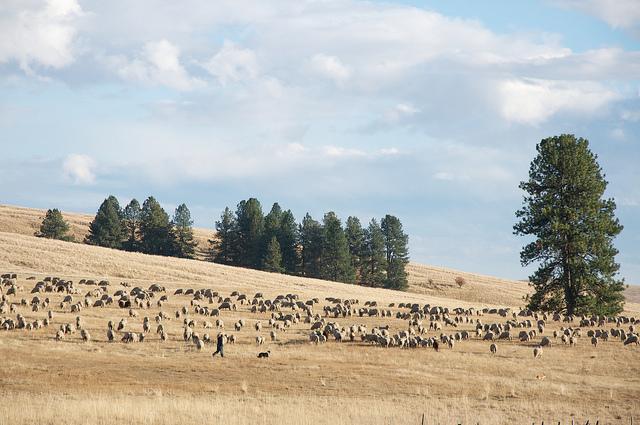What is the most probable reason there is a dog here?
Choose the right answer from the provided options to respond to the question.
Options: Help blind, sniff bombs, watch house, heard animals. Heard animals. 